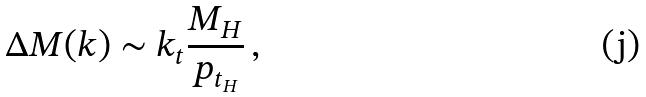Convert formula to latex. <formula><loc_0><loc_0><loc_500><loc_500>\Delta M ( k ) \sim k _ { t } \frac { M _ { H } } { p _ { t _ { H } } } \, ,</formula> 